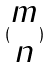<formula> <loc_0><loc_0><loc_500><loc_500>( \begin{matrix} m \\ n \end{matrix} )</formula> 